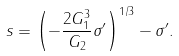<formula> <loc_0><loc_0><loc_500><loc_500>s = \left ( - \frac { 2 G _ { 1 } ^ { 3 } } { G _ { 2 } } \sigma ^ { \prime } \right ) ^ { 1 / 3 } - \sigma ^ { \prime } .</formula> 